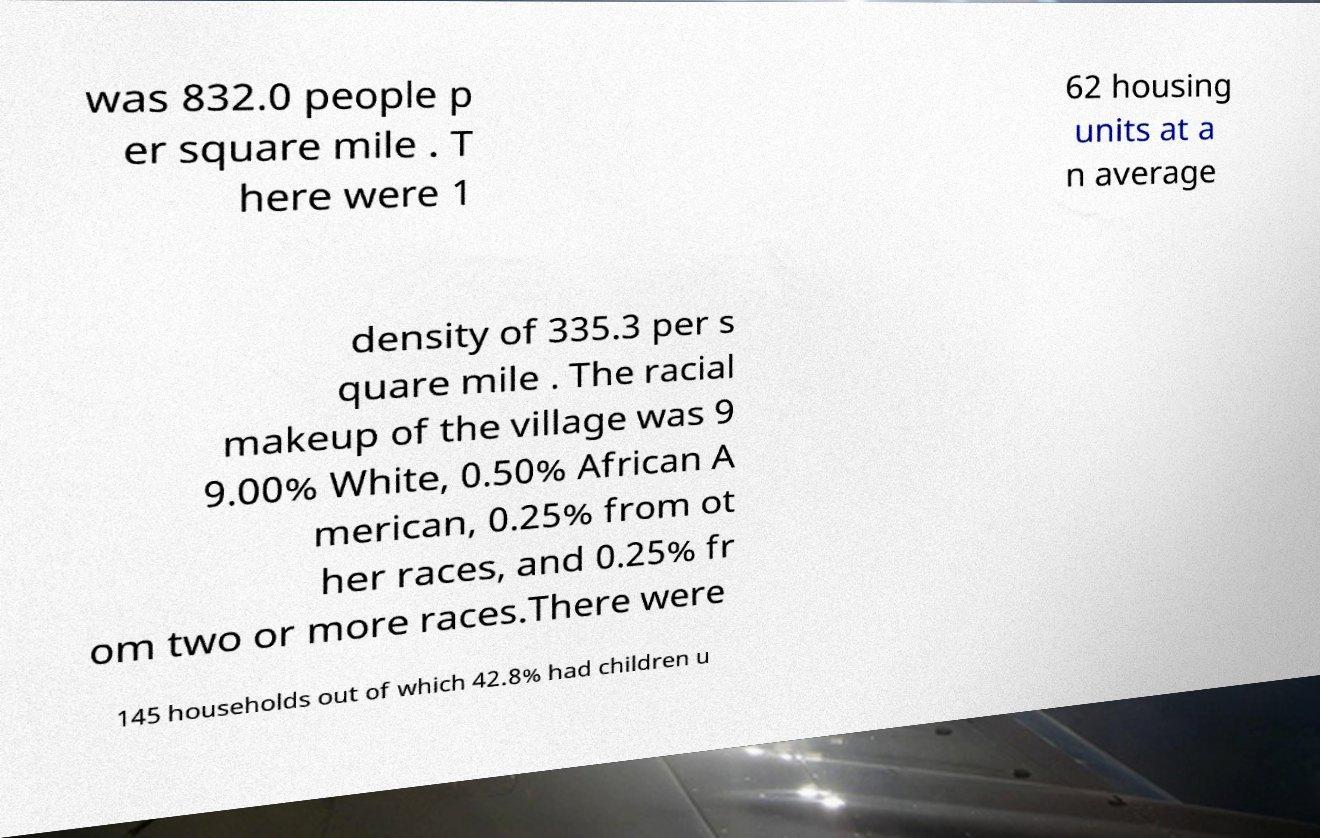Please identify and transcribe the text found in this image. was 832.0 people p er square mile . T here were 1 62 housing units at a n average density of 335.3 per s quare mile . The racial makeup of the village was 9 9.00% White, 0.50% African A merican, 0.25% from ot her races, and 0.25% fr om two or more races.There were 145 households out of which 42.8% had children u 